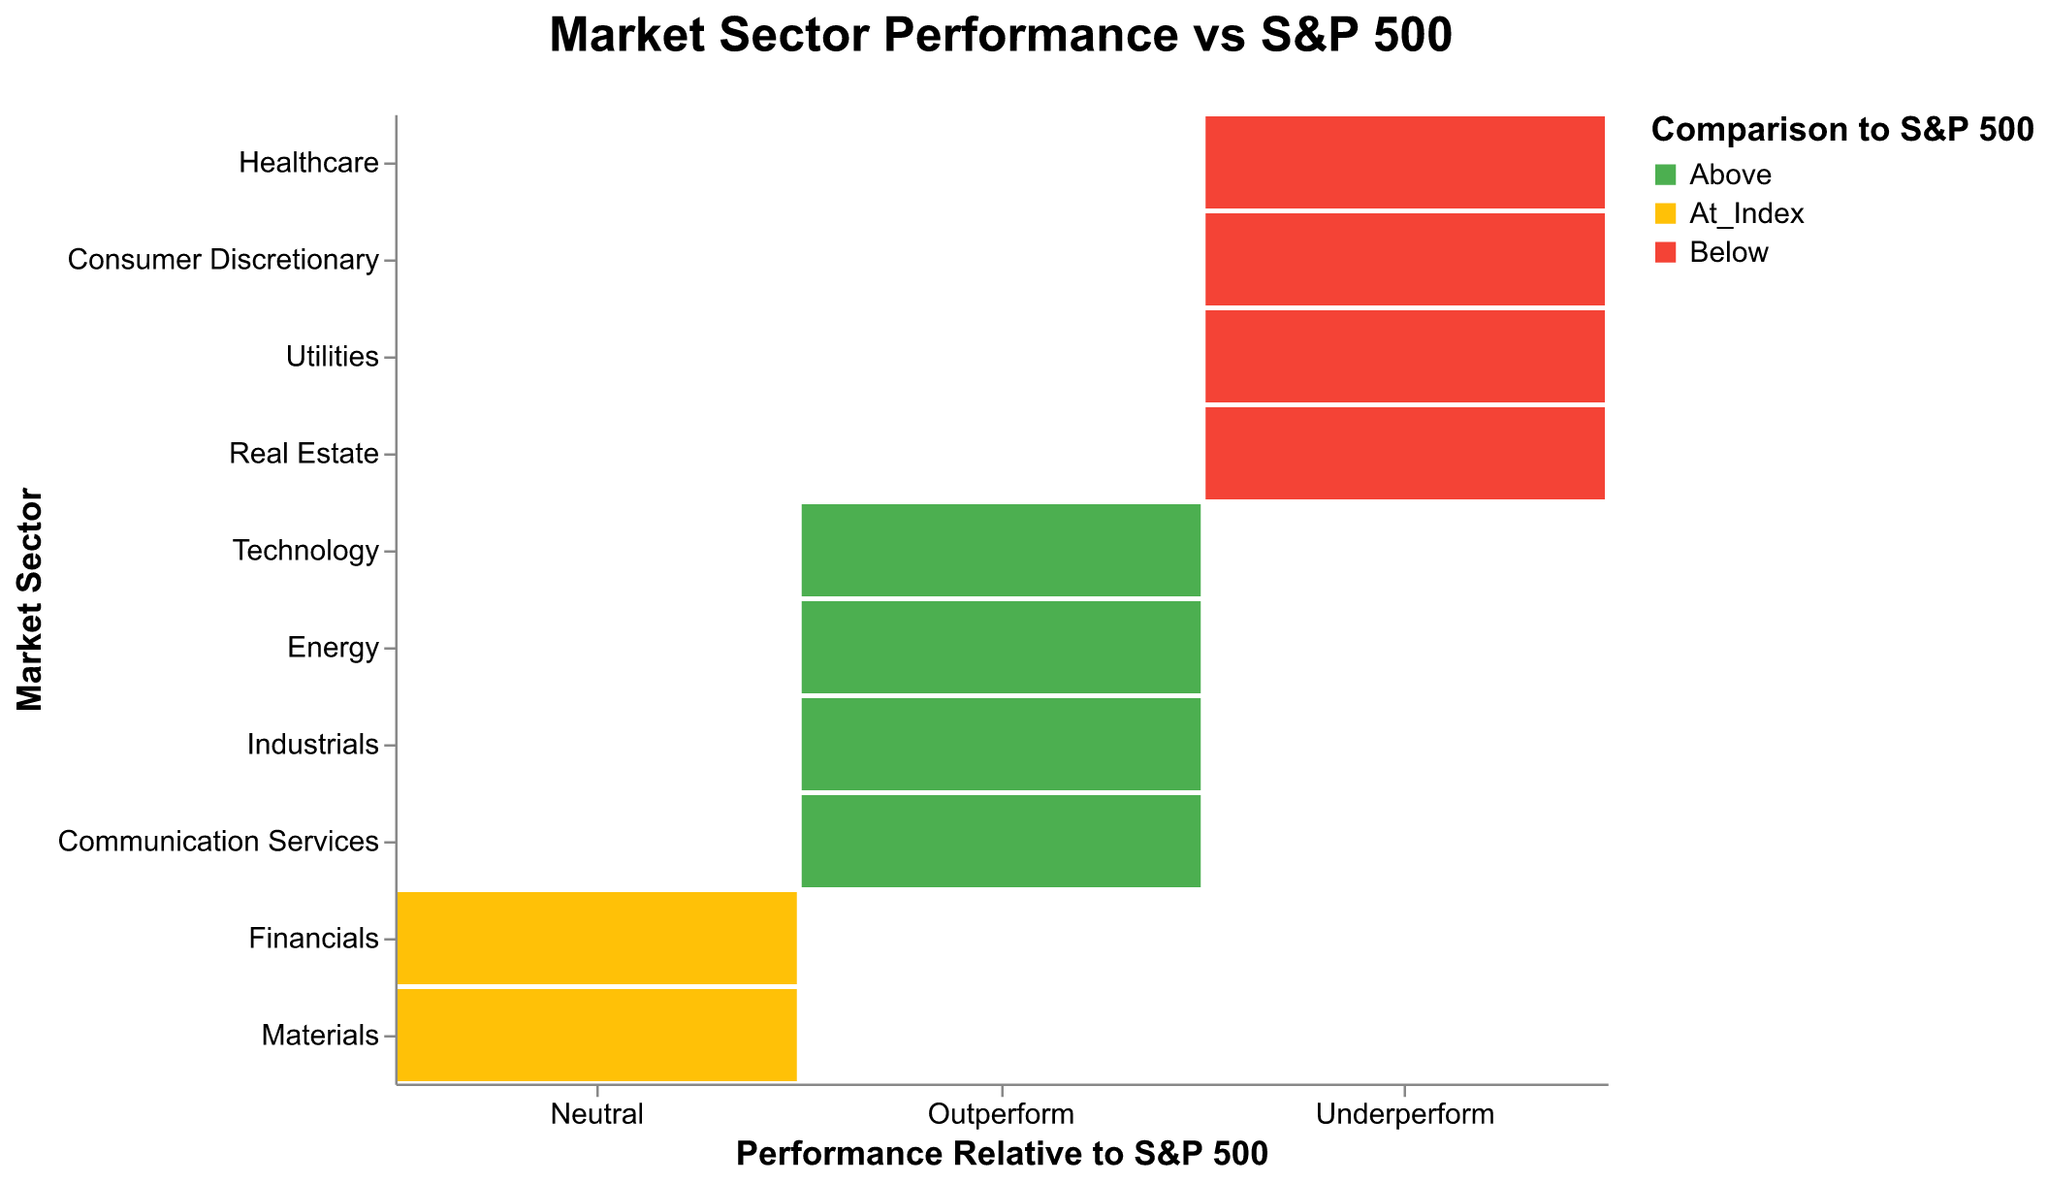What is the title of the figure? The title is displayed at the top of the figure and reads "Market Sector Performance vs S&P 500".
Answer: Market Sector Performance vs S&P 500 How many sectors are depicted in the figure? Count the number of distinct sectors listed on the y-axis.
Answer: 10 Which sectors are marked as "Above" the S&P 500? Identify sectors with cells colored in green that represent the "Above" category.
Answer: Technology, Energy, Industrials, Communication Services Which sector is marked with a "Neutral" performance relative to the S&P 500? Look for the sector colored in yellow, which indicates a "Neutral" performance.
Answer: Financials, Materials Are there more sectors that underperform or outperform the S&P 500? Count the sectors marked in red (Underperform) and those marked in green (Outperform). Then compare the two counts.
Answer: More sectors underperform (4 sectors outperform, 5 sectors underperform) How many sectors are classified as "Underperform" and "Below" the S&P 500? Count the sectors presented in red under the "Underperform" performance column.
Answer: Four sectors Which sectors both outperform the S&P 500 and fall under the "Above" category? Look for sectors colored green in the "Outperform" column.
Answer: Technology, Energy, Industrials, Communication Services Do any sectors match the S&P 500 index in their performance? Identify any sectors colored yellow in the "Neutral" columns.
Answer: Financials, Materials Compare the "Underperform" sectors to the "Outperform" sectors. Which group is larger? Count the sectors under the "Underperform" and "Outperform" columns and compare the numbers.
Answer: "Underperform" group is larger How many sectors both underperform and are below the S&P 500? Count the sectors marked in red under the "Underperform" category that are categorized as "Below" the S&P 500 on the color legend.
Answer: 4 